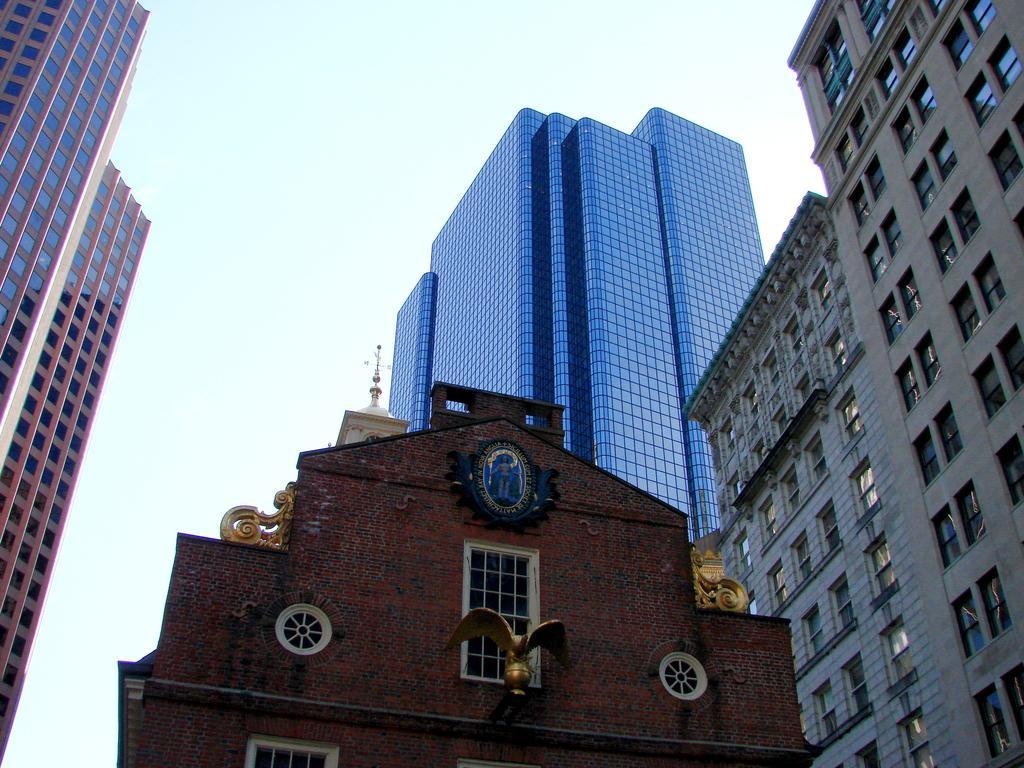Please provide a concise description of this image. In this image I can see buildings and the sky. 